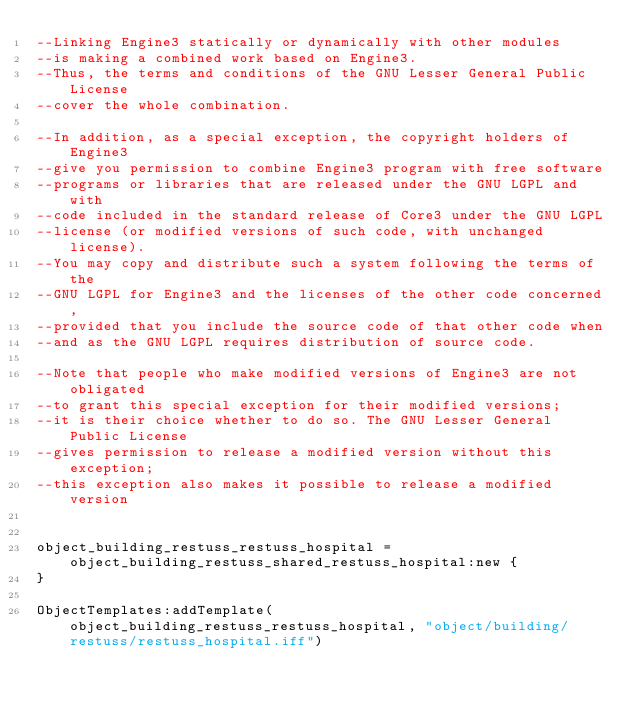Convert code to text. <code><loc_0><loc_0><loc_500><loc_500><_Lua_>--Linking Engine3 statically or dynamically with other modules 
--is making a combined work based on Engine3. 
--Thus, the terms and conditions of the GNU Lesser General Public License 
--cover the whole combination.

--In addition, as a special exception, the copyright holders of Engine3 
--give you permission to combine Engine3 program with free software 
--programs or libraries that are released under the GNU LGPL and with 
--code included in the standard release of Core3 under the GNU LGPL 
--license (or modified versions of such code, with unchanged license). 
--You may copy and distribute such a system following the terms of the 
--GNU LGPL for Engine3 and the licenses of the other code concerned, 
--provided that you include the source code of that other code when 
--and as the GNU LGPL requires distribution of source code.

--Note that people who make modified versions of Engine3 are not obligated 
--to grant this special exception for their modified versions; 
--it is their choice whether to do so. The GNU Lesser General Public License 
--gives permission to release a modified version without this exception; 
--this exception also makes it possible to release a modified version 


object_building_restuss_restuss_hospital = object_building_restuss_shared_restuss_hospital:new {
}

ObjectTemplates:addTemplate(object_building_restuss_restuss_hospital, "object/building/restuss/restuss_hospital.iff")
</code> 